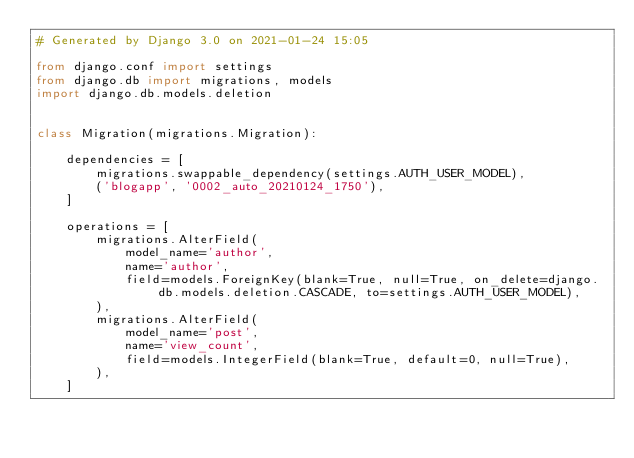Convert code to text. <code><loc_0><loc_0><loc_500><loc_500><_Python_># Generated by Django 3.0 on 2021-01-24 15:05

from django.conf import settings
from django.db import migrations, models
import django.db.models.deletion


class Migration(migrations.Migration):

    dependencies = [
        migrations.swappable_dependency(settings.AUTH_USER_MODEL),
        ('blogapp', '0002_auto_20210124_1750'),
    ]

    operations = [
        migrations.AlterField(
            model_name='author',
            name='author',
            field=models.ForeignKey(blank=True, null=True, on_delete=django.db.models.deletion.CASCADE, to=settings.AUTH_USER_MODEL),
        ),
        migrations.AlterField(
            model_name='post',
            name='view_count',
            field=models.IntegerField(blank=True, default=0, null=True),
        ),
    ]
</code> 